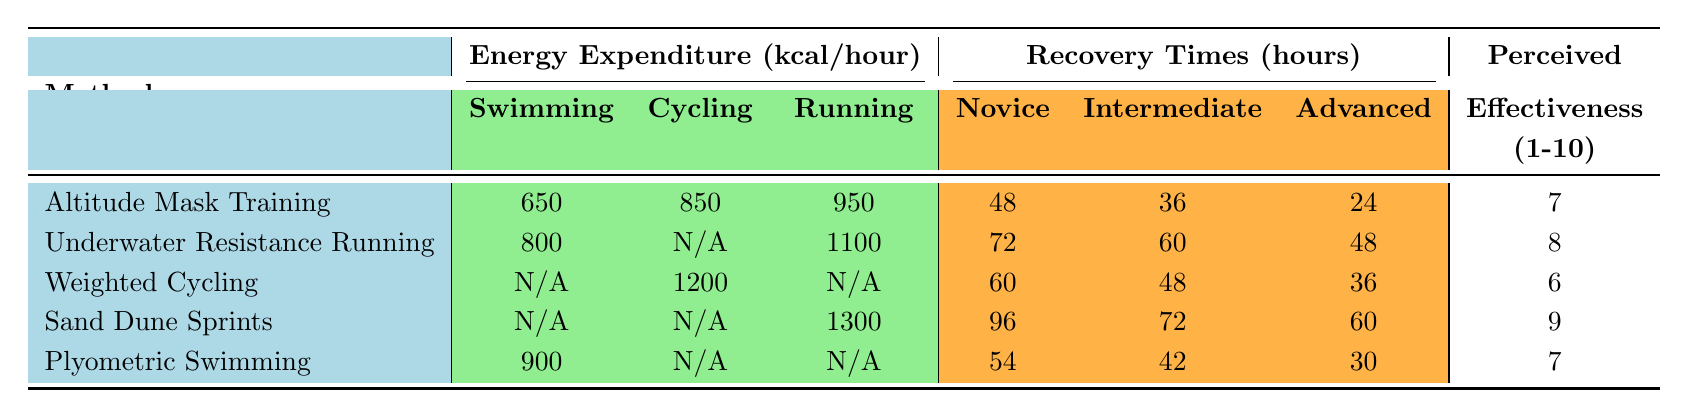What is the energy expenditure for swimming in Altitude Mask Training? The table shows "650" kcal/hour under the Swimming column for the Altitude Mask Training method.
Answer: 650 What are the recovery times for Advanced level in Plyometric Swimming? For Plyometric Swimming, the Advanced level recovery time is listed as "30" hours in the Recovery Times section of the table.
Answer: 30 Which training method has the highest energy expenditure for running? By comparing the Running energy expenditure values, Sand Dune Sprints has "1300" kcal/hour, which is the highest among the listed methods.
Answer: Sand Dune Sprints Is there a method that reports energy expenditure for both swimming and cycling? Yes, the Underwater Resistance Running method reports energy expenditure for swimming as "800" and for cycling as "N/A," indicating that it does not have a value for cycling.
Answer: Yes What is the average perceived effectiveness rating for the listed training methods? To find the average effectiveness, sum the ratings (7 + 8 + 6 + 9 + 7 = 37) and divide by the number of methods (5): 37/5 = 7.4.
Answer: 7.4 Which method has the longest recovery time for novice trainees? The recovery times for novice trainees are 48, 72, 60, 96, and 54 hours for different methods. The longest time is 96 hours for Sand Dune Sprints.
Answer: Sand Dune Sprints Does Weighted Cycling have an energy expenditure value for swimming? Under the Weighted Cycling method in the table, the energy expenditure for swimming is marked as "N/A," indicating no value is provided.
Answer: No Which method has the greatest difference in recovery time between novice and advanced levels? The differences are calculated as follows: Altitude Mask Training (48 - 24 = 24), Underwater Resistance Running (72 - 48 = 24), Weighted Cycling (60 - 36 = 24), Sand Dune Sprints (96 - 60 = 36), and Plyometric Swimming (54 - 30 = 24). The greatest difference, 36 hours, is for Sand Dune Sprints.
Answer: Sand Dune Sprints What percentage of energy expenditure from underwater resistance running is attributed to the running activity? The total energy expenditure for Underwater Resistance Running (running = 1100, swimming = 800; cycling = N/A) is 1100 + 800 = 1900 kcal. The percentage attributed to running is (1100/1900) * 100 = 57.89%.
Answer: 57.89% In what training method is the energy expenditure for cycling the highest, and how much is it? The table shows that Weighted Cycling has the highest energy expenditure for cycling at 1200 kcal/hour.
Answer: Weighted Cycling, 1200 